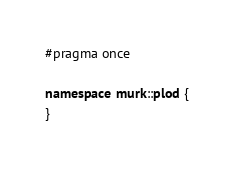<code> <loc_0><loc_0><loc_500><loc_500><_C++_>#pragma once

namespace murk::plod {
}
</code> 